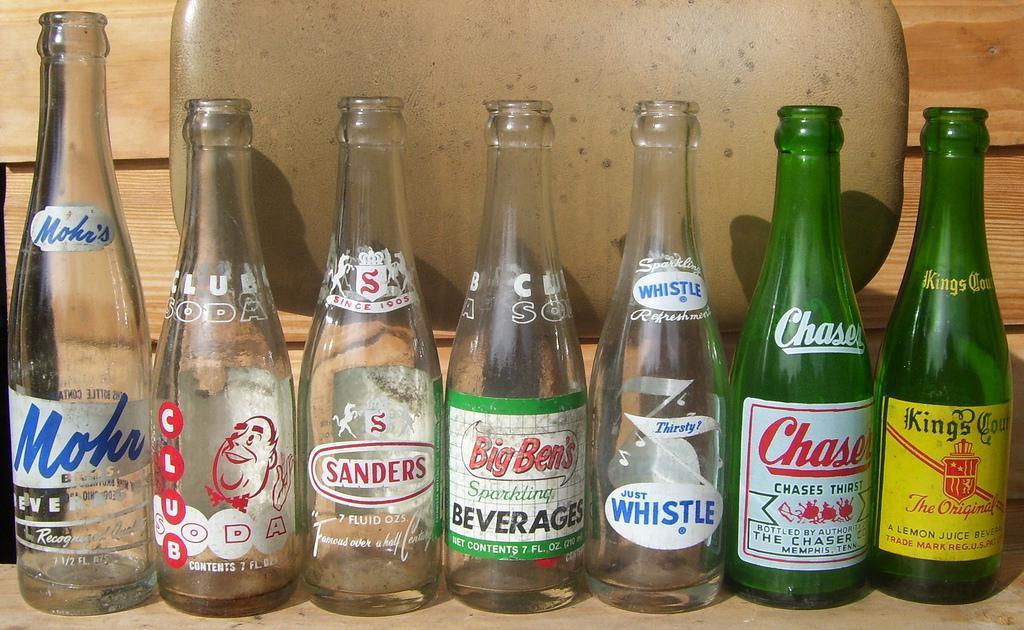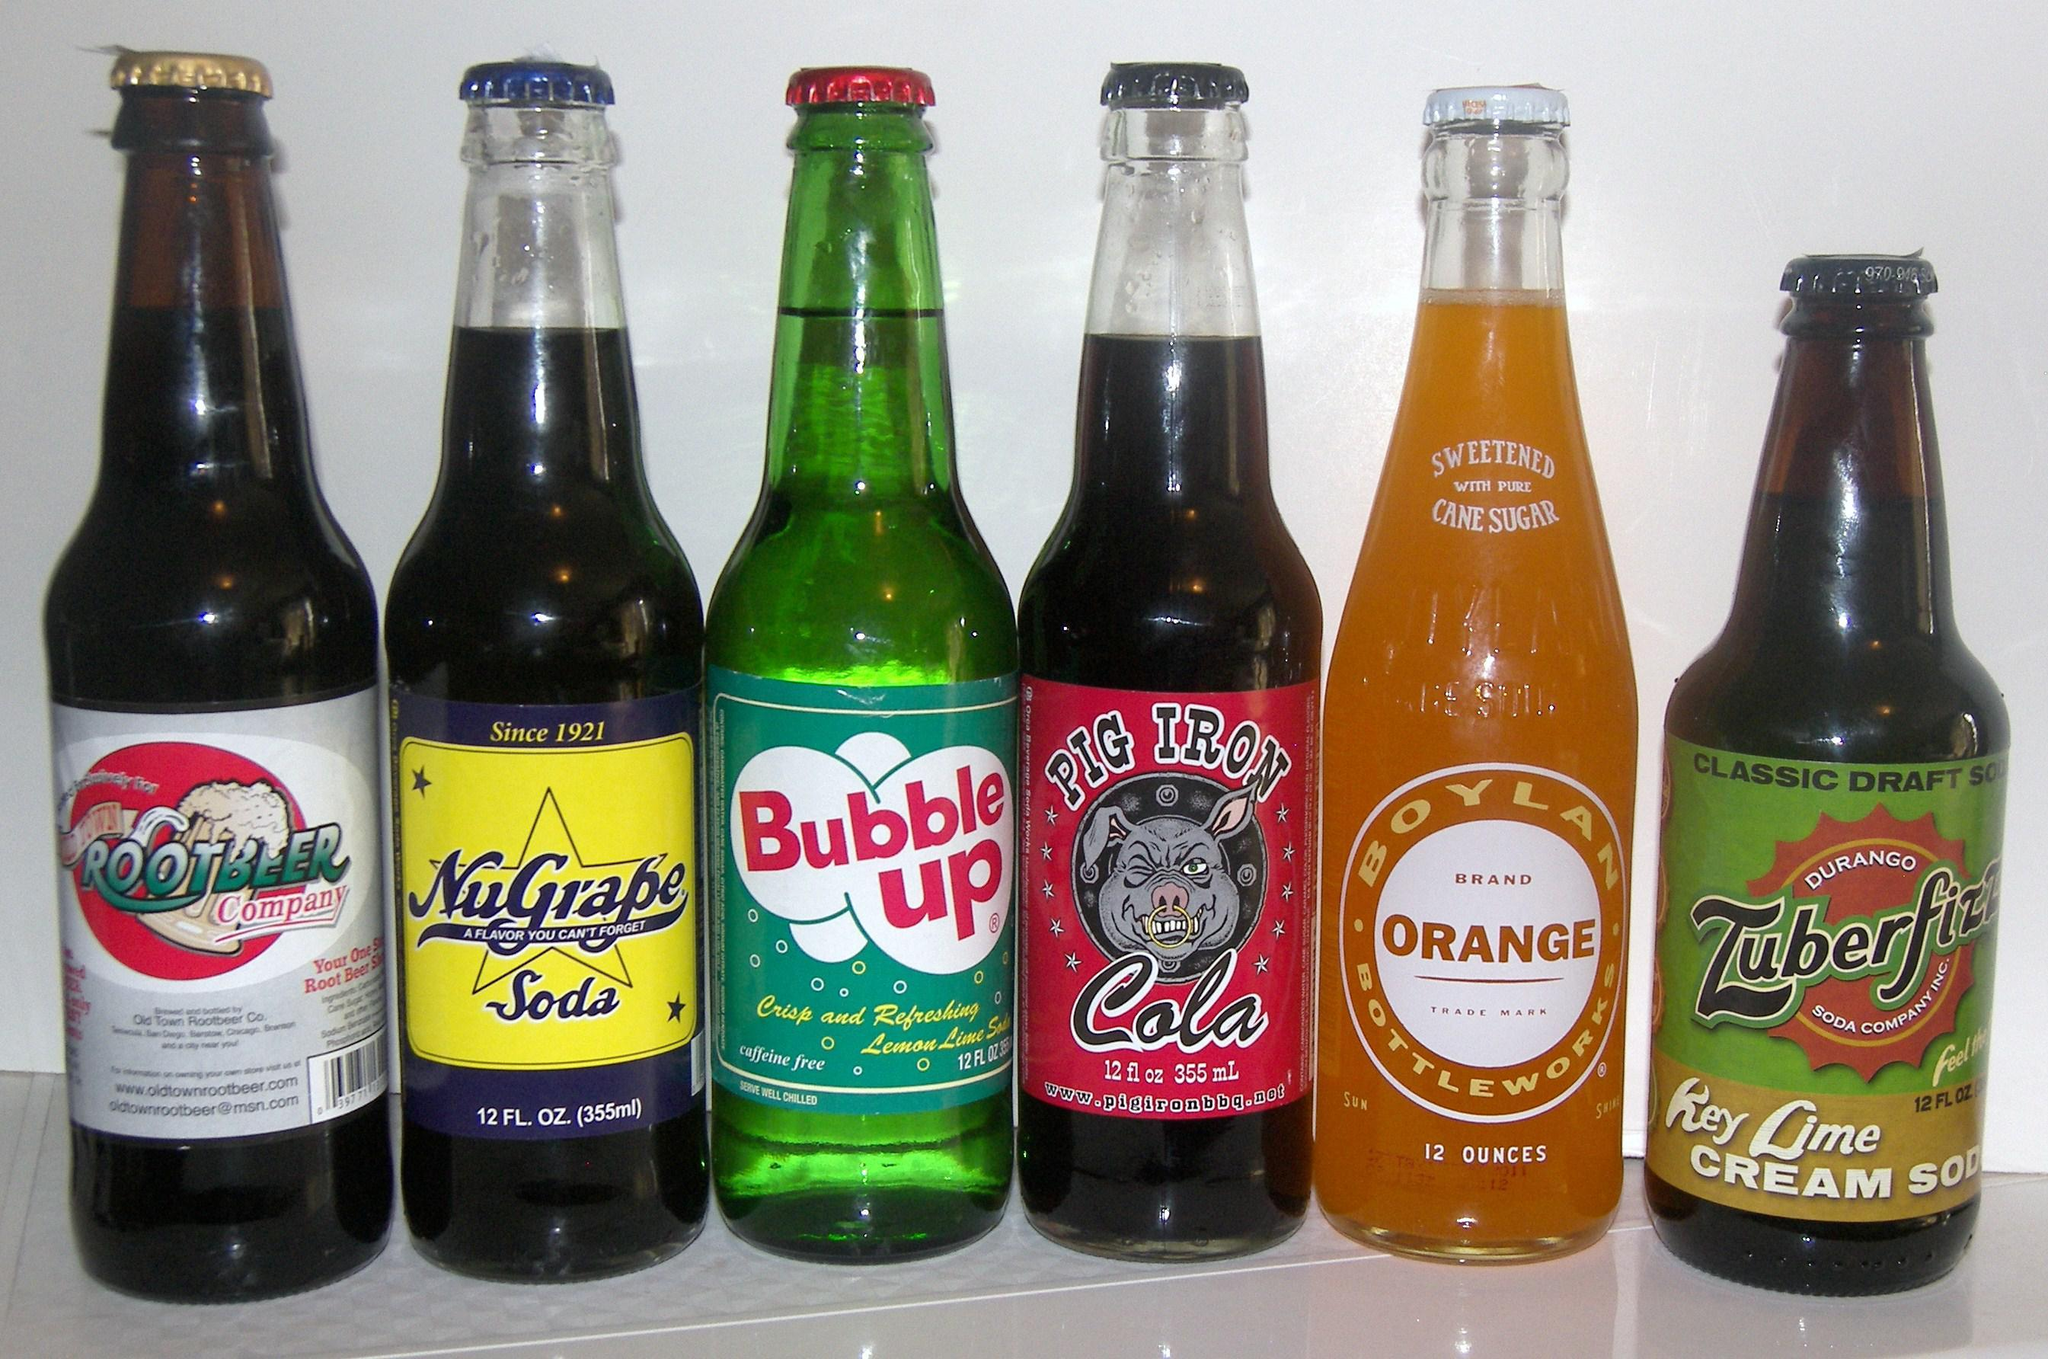The first image is the image on the left, the second image is the image on the right. Assess this claim about the two images: "The left image features a row of at least six empty soda bottles without lids, and the right image shows exactly six filled bottles of soda with caps on.". Correct or not? Answer yes or no. Yes. The first image is the image on the left, the second image is the image on the right. Assess this claim about the two images: "There are exactly six bottles in the right image.". Correct or not? Answer yes or no. Yes. 